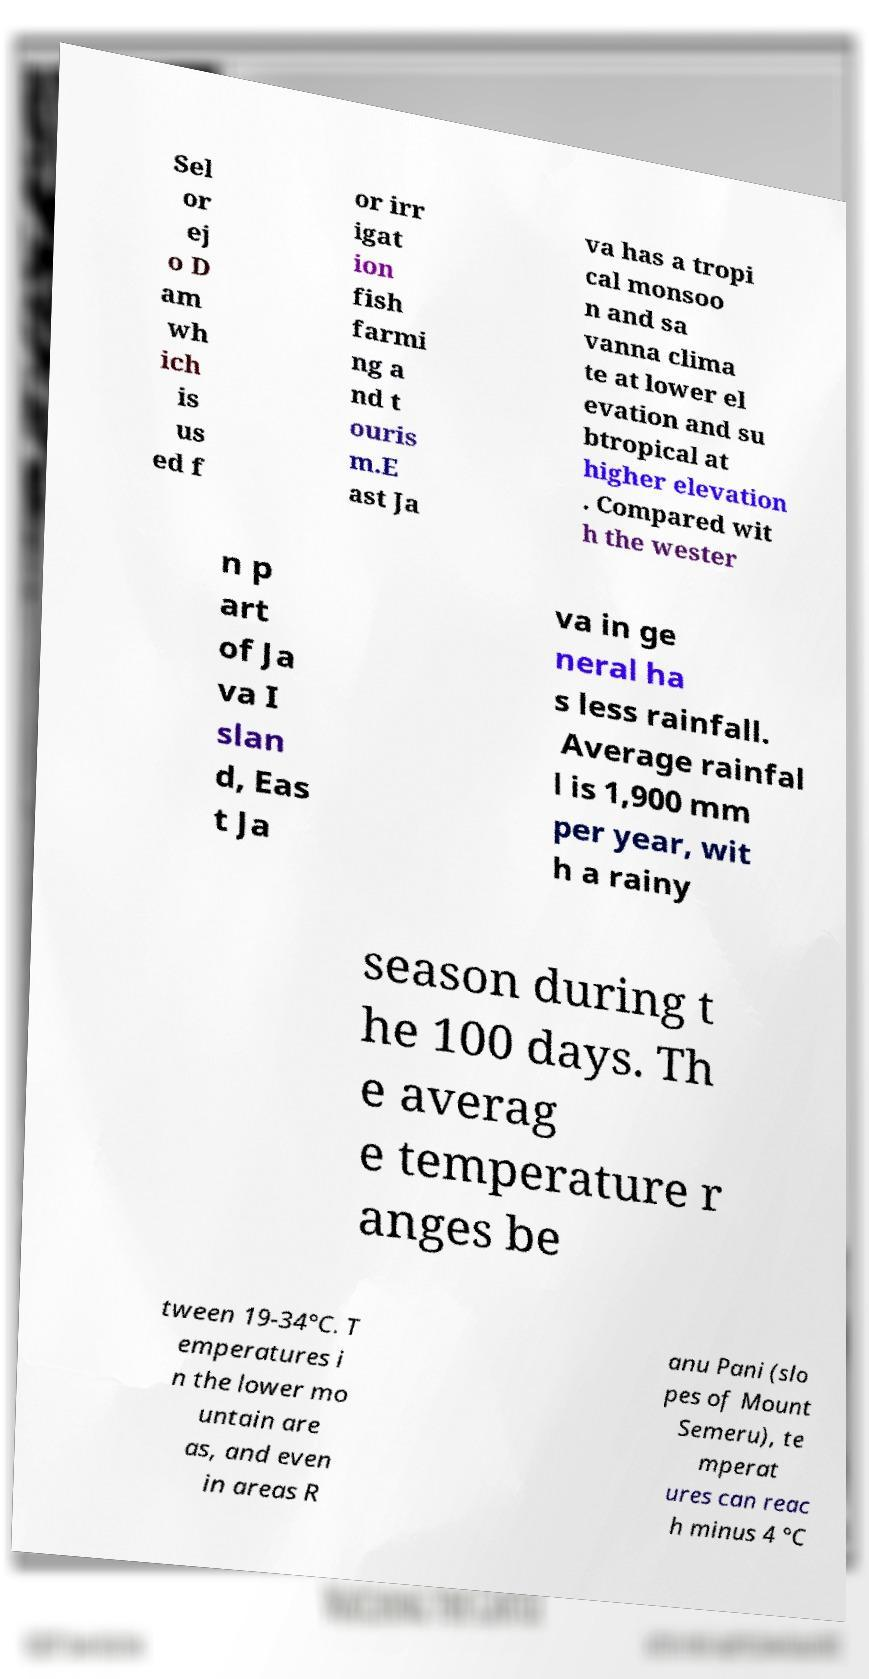What messages or text are displayed in this image? I need them in a readable, typed format. Sel or ej o D am wh ich is us ed f or irr igat ion fish farmi ng a nd t ouris m.E ast Ja va has a tropi cal monsoo n and sa vanna clima te at lower el evation and su btropical at higher elevation . Compared wit h the wester n p art of Ja va I slan d, Eas t Ja va in ge neral ha s less rainfall. Average rainfal l is 1,900 mm per year, wit h a rainy season during t he 100 days. Th e averag e temperature r anges be tween 19-34°C. T emperatures i n the lower mo untain are as, and even in areas R anu Pani (slo pes of Mount Semeru), te mperat ures can reac h minus 4 °C 